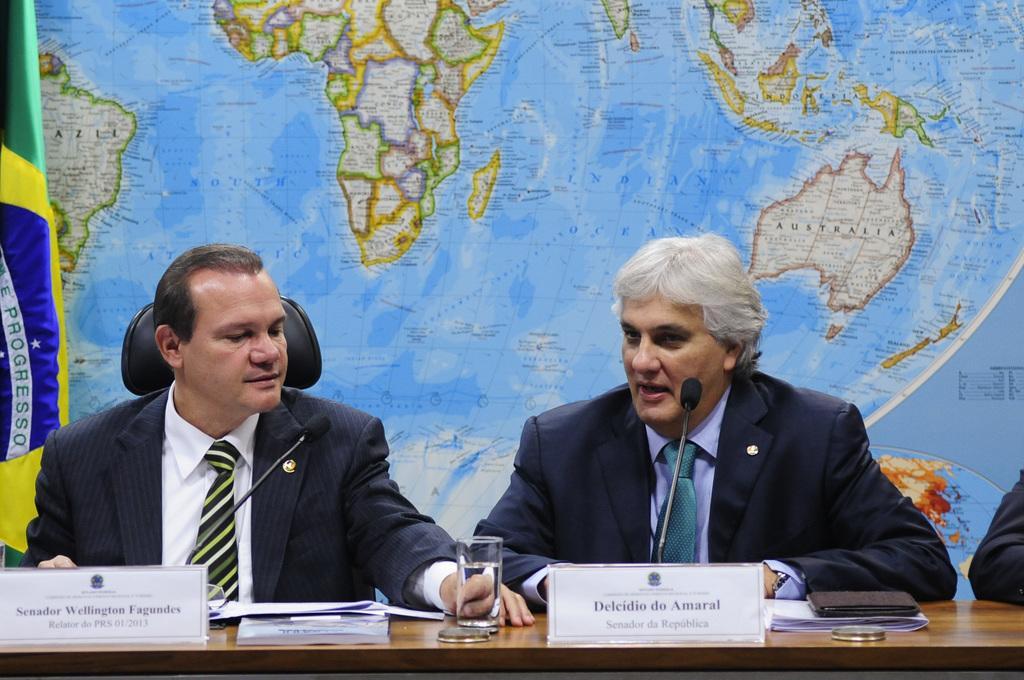Could you give a brief overview of what you see in this image? In this image there are two people sitting on the chairs in front of table where we can see there are some papers, microphones, glass with water and name boards behind them there is a wall with map and flag at the corner. 